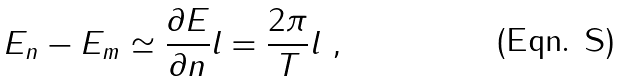Convert formula to latex. <formula><loc_0><loc_0><loc_500><loc_500>E _ { n } - E _ { m } \simeq \frac { \partial E } { \partial n } l = \frac { 2 \pi } { T } l \ ,</formula> 